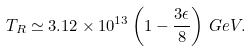<formula> <loc_0><loc_0><loc_500><loc_500>T _ { R } \simeq 3 . 1 2 \times 1 0 ^ { 1 3 } \left ( 1 - \frac { 3 \epsilon } { 8 } \right ) \, G e V .</formula> 